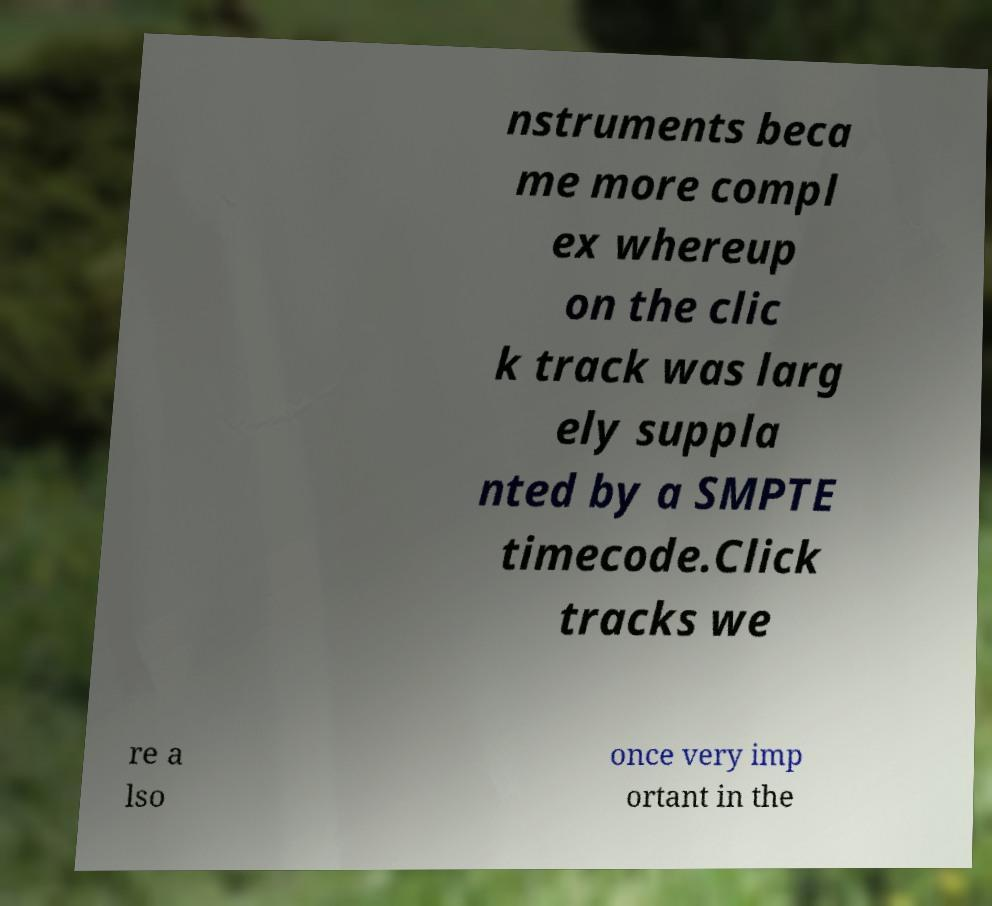There's text embedded in this image that I need extracted. Can you transcribe it verbatim? nstruments beca me more compl ex whereup on the clic k track was larg ely suppla nted by a SMPTE timecode.Click tracks we re a lso once very imp ortant in the 